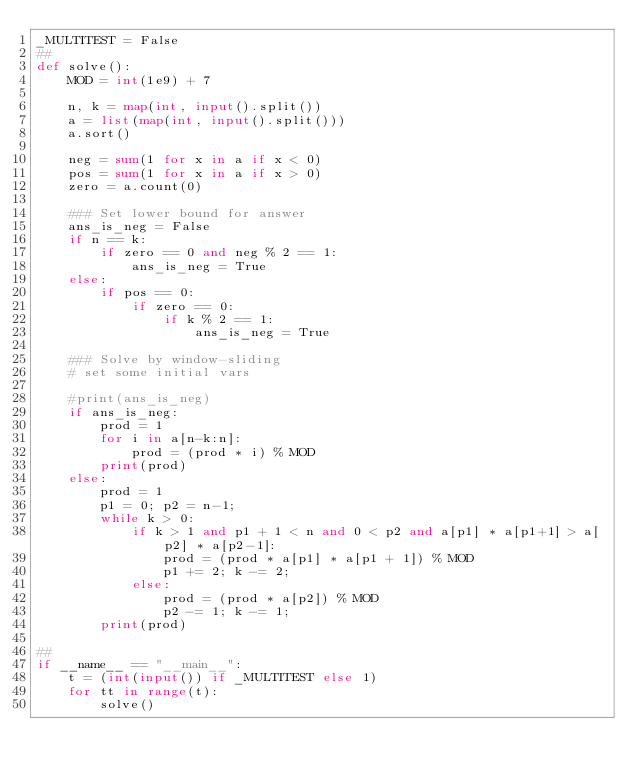<code> <loc_0><loc_0><loc_500><loc_500><_Python_>_MULTITEST = False
##
def solve():
    MOD = int(1e9) + 7

    n, k = map(int, input().split())
    a = list(map(int, input().split()))
    a.sort()

    neg = sum(1 for x in a if x < 0)
    pos = sum(1 for x in a if x > 0)
    zero = a.count(0)
    
    ### Set lower bound for answer
    ans_is_neg = False
    if n == k:
        if zero == 0 and neg % 2 == 1:
            ans_is_neg = True
    else:
        if pos == 0:
            if zero == 0:
                if k % 2 == 1:
                    ans_is_neg = True
    
    ### Solve by window-sliding
    # set some initial vars

    #print(ans_is_neg)
    if ans_is_neg:
        prod = 1
        for i in a[n-k:n]:
            prod = (prod * i) % MOD
        print(prod)
    else:
        prod = 1
        p1 = 0; p2 = n-1;
        while k > 0:
            if k > 1 and p1 + 1 < n and 0 < p2 and a[p1] * a[p1+1] > a[p2] * a[p2-1]:
                prod = (prod * a[p1] * a[p1 + 1]) % MOD
                p1 += 2; k -= 2;
            else:
                prod = (prod * a[p2]) % MOD
                p2 -= 1; k -= 1;
        print(prod)

##
if __name__ == "__main__":
    t = (int(input()) if _MULTITEST else 1)
    for tt in range(t):
        solve()</code> 